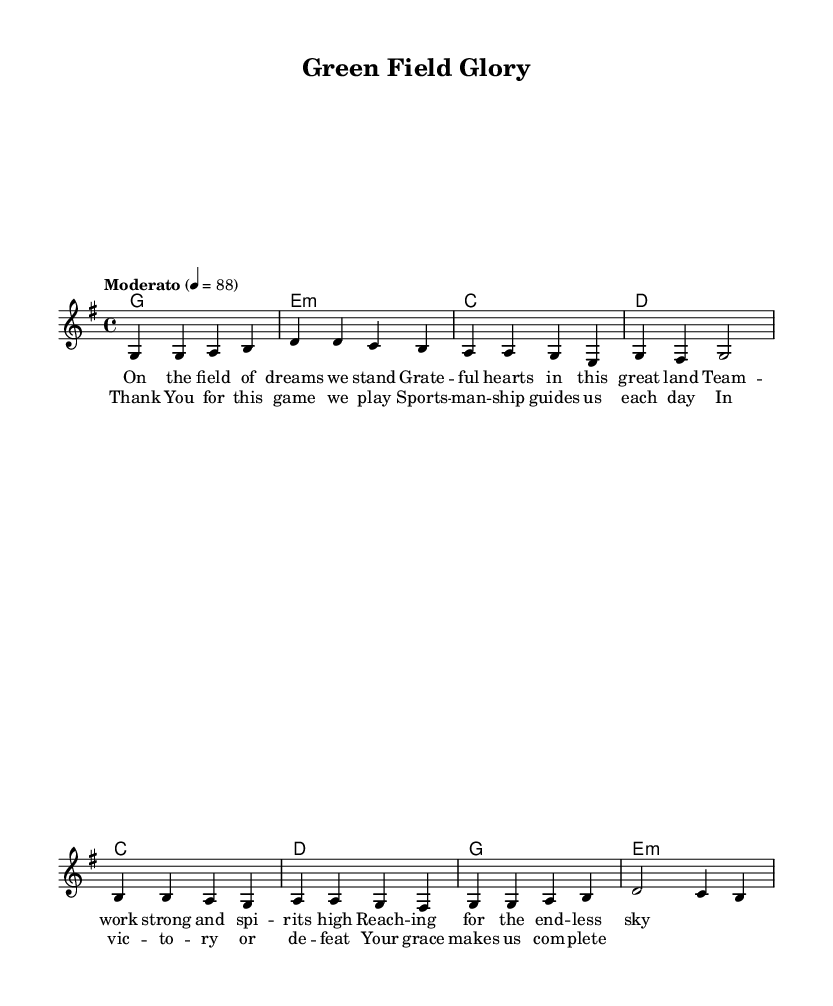What is the key signature of this music? The key signature is G major, which has one sharp (F#). This can be identified from the key signature indicator placed at the beginning of the sheet music.
Answer: G major What is the time signature of the piece? The time signature is 4/4, indicated directly in the music notation. This means there are four beats in each measure and the quarter note gets one beat.
Answer: 4/4 What is the tempo marking for the piece? The tempo marking states "Moderato" with a metronome mark of 88, which indicates a moderate speed. This is located at the beginning of the score under the header.
Answer: Moderato 88 How many verses are indicated in the lyrics? The score includes one verse section before the chorus, as seen in the structure of the song where "verse" is clearly labeled.
Answer: One verse Which chords are used in the chorus? The chords in the chorus are C, D, G, and E minor, which can be found in the chord symbols written above the corresponding melody notes in the chorus section.
Answer: C, D, G, E minor What theme is emphasized in the lyrics? The lyrics emphasize gratitude and sportsmanship, as evident in phrases referring to grateful hearts and the guiding principle of sportsmanship throughout both the verse and chorus.
Answer: Gratitude and sportsmanship 